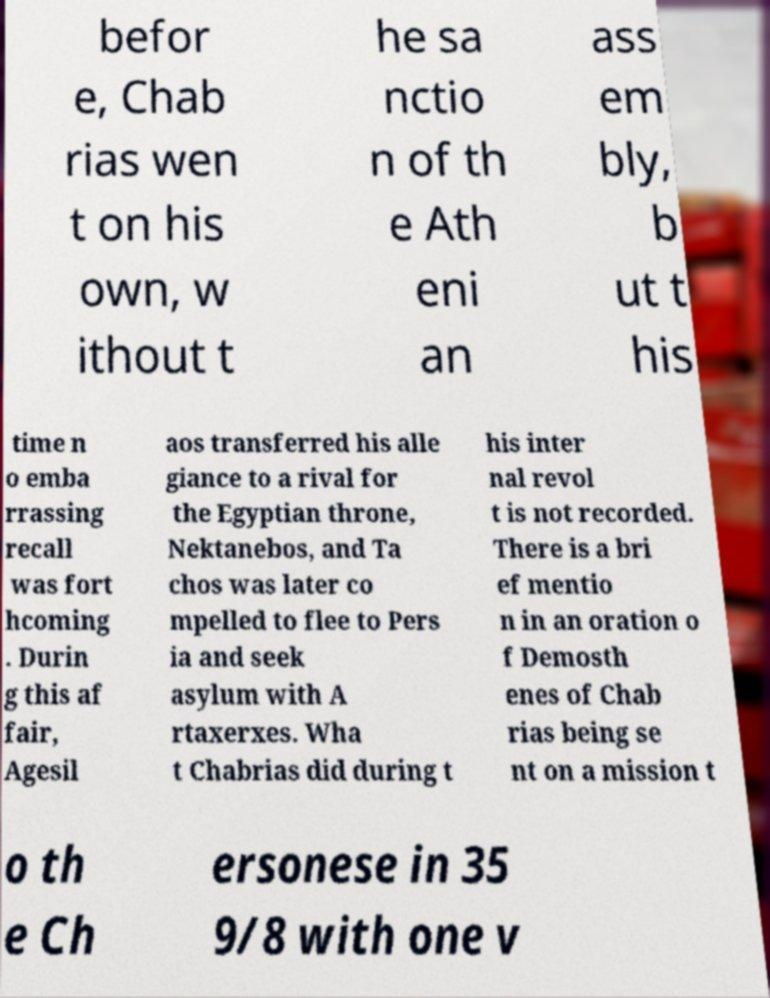Please read and relay the text visible in this image. What does it say? befor e, Chab rias wen t on his own, w ithout t he sa nctio n of th e Ath eni an ass em bly, b ut t his time n o emba rrassing recall was fort hcoming . Durin g this af fair, Agesil aos transferred his alle giance to a rival for the Egyptian throne, Nektanebos, and Ta chos was later co mpelled to flee to Pers ia and seek asylum with A rtaxerxes. Wha t Chabrias did during t his inter nal revol t is not recorded. There is a bri ef mentio n in an oration o f Demosth enes of Chab rias being se nt on a mission t o th e Ch ersonese in 35 9/8 with one v 